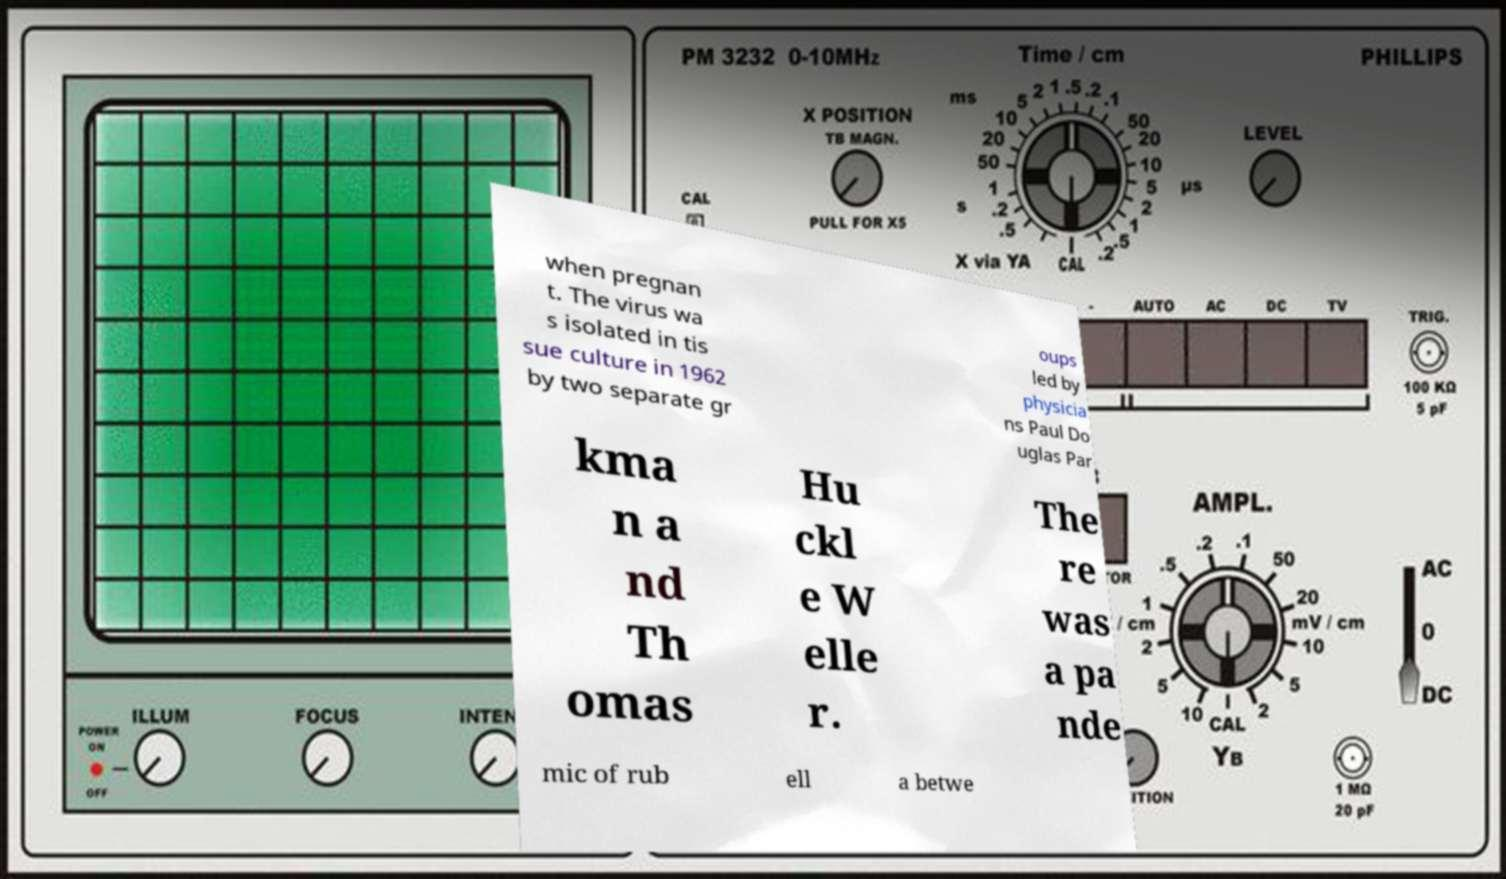For documentation purposes, I need the text within this image transcribed. Could you provide that? when pregnan t. The virus wa s isolated in tis sue culture in 1962 by two separate gr oups led by physicia ns Paul Do uglas Par kma n a nd Th omas Hu ckl e W elle r. The re was a pa nde mic of rub ell a betwe 